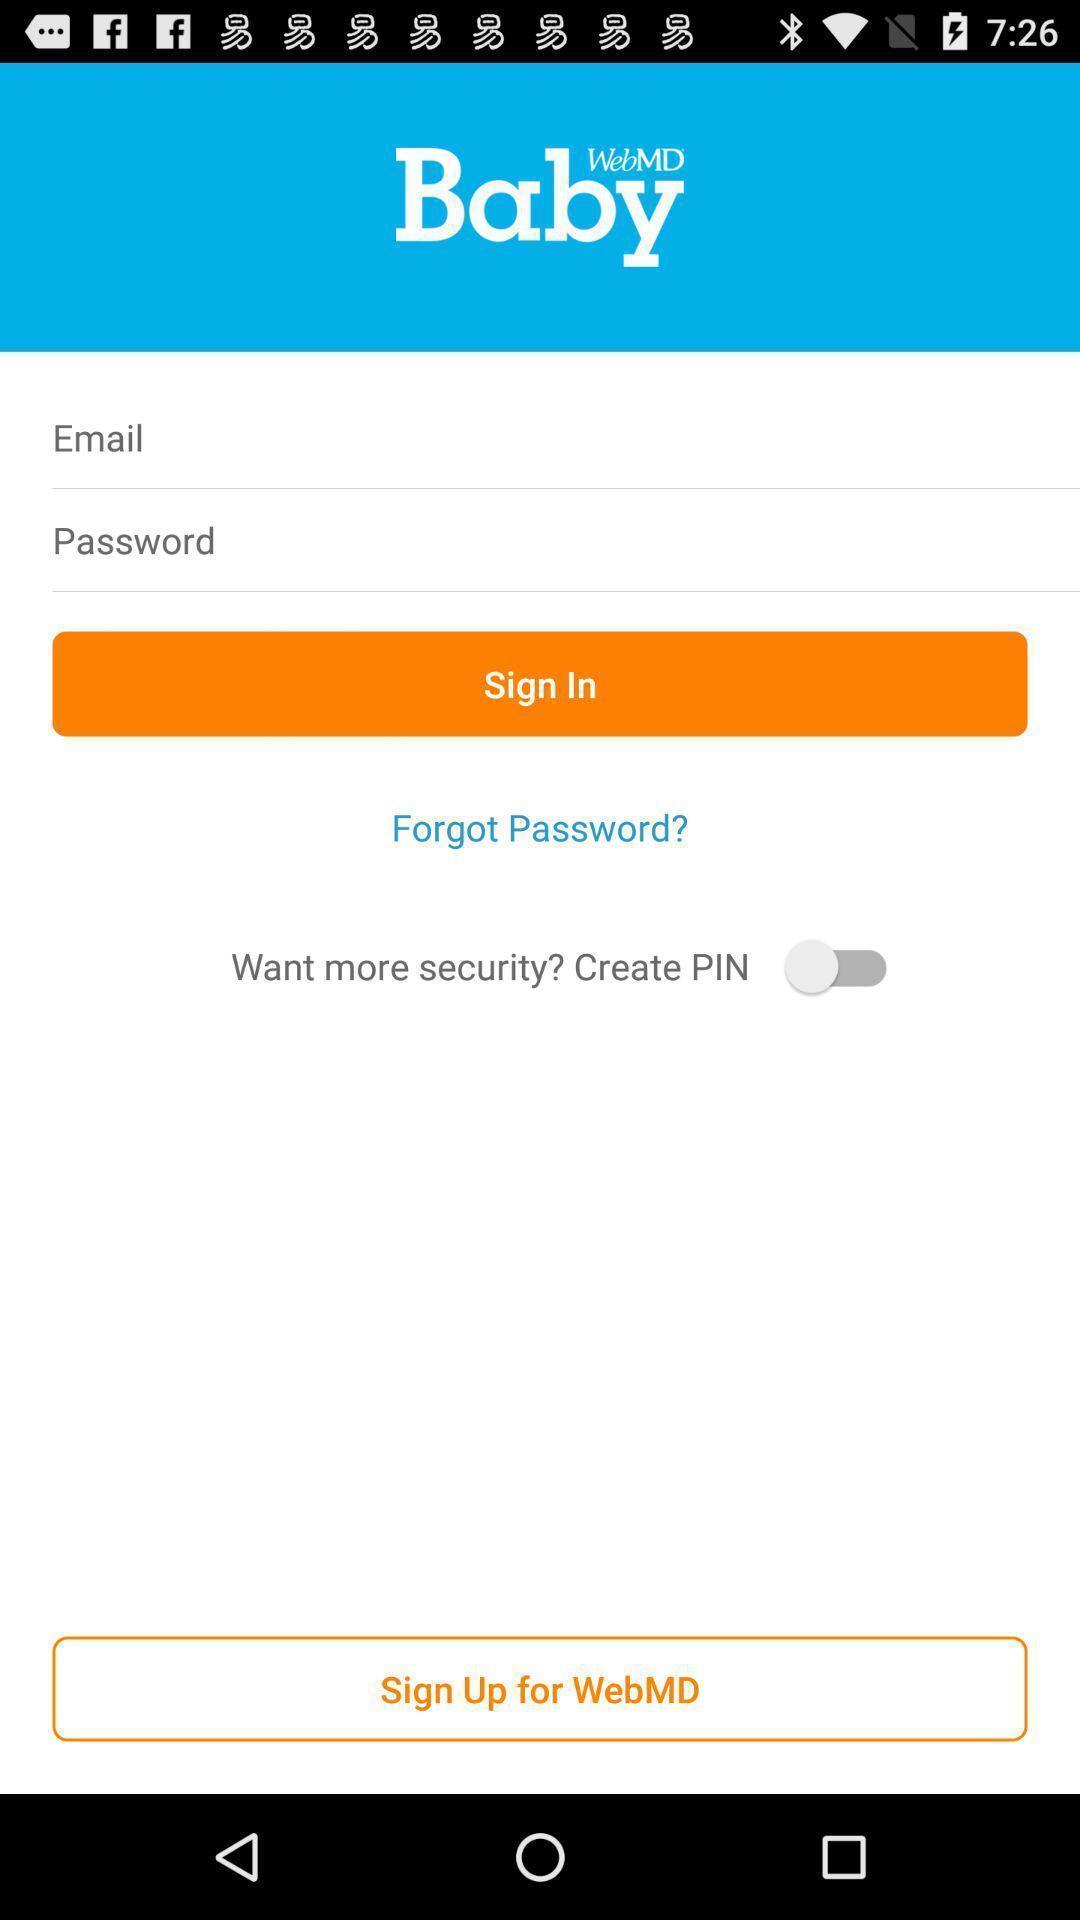Please provide a description for this image. Sign in page of baby development tracker application. 